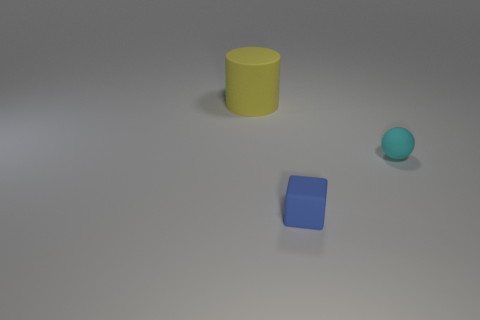Add 3 yellow metallic balls. How many objects exist? 6 Subtract 1 balls. How many balls are left? 0 Subtract all cubes. How many objects are left? 2 Subtract all purple metallic cylinders. Subtract all large things. How many objects are left? 2 Add 1 tiny blue cubes. How many tiny blue cubes are left? 2 Add 1 cyan rubber objects. How many cyan rubber objects exist? 2 Subtract 1 yellow cylinders. How many objects are left? 2 Subtract all purple spheres. Subtract all red cylinders. How many spheres are left? 1 